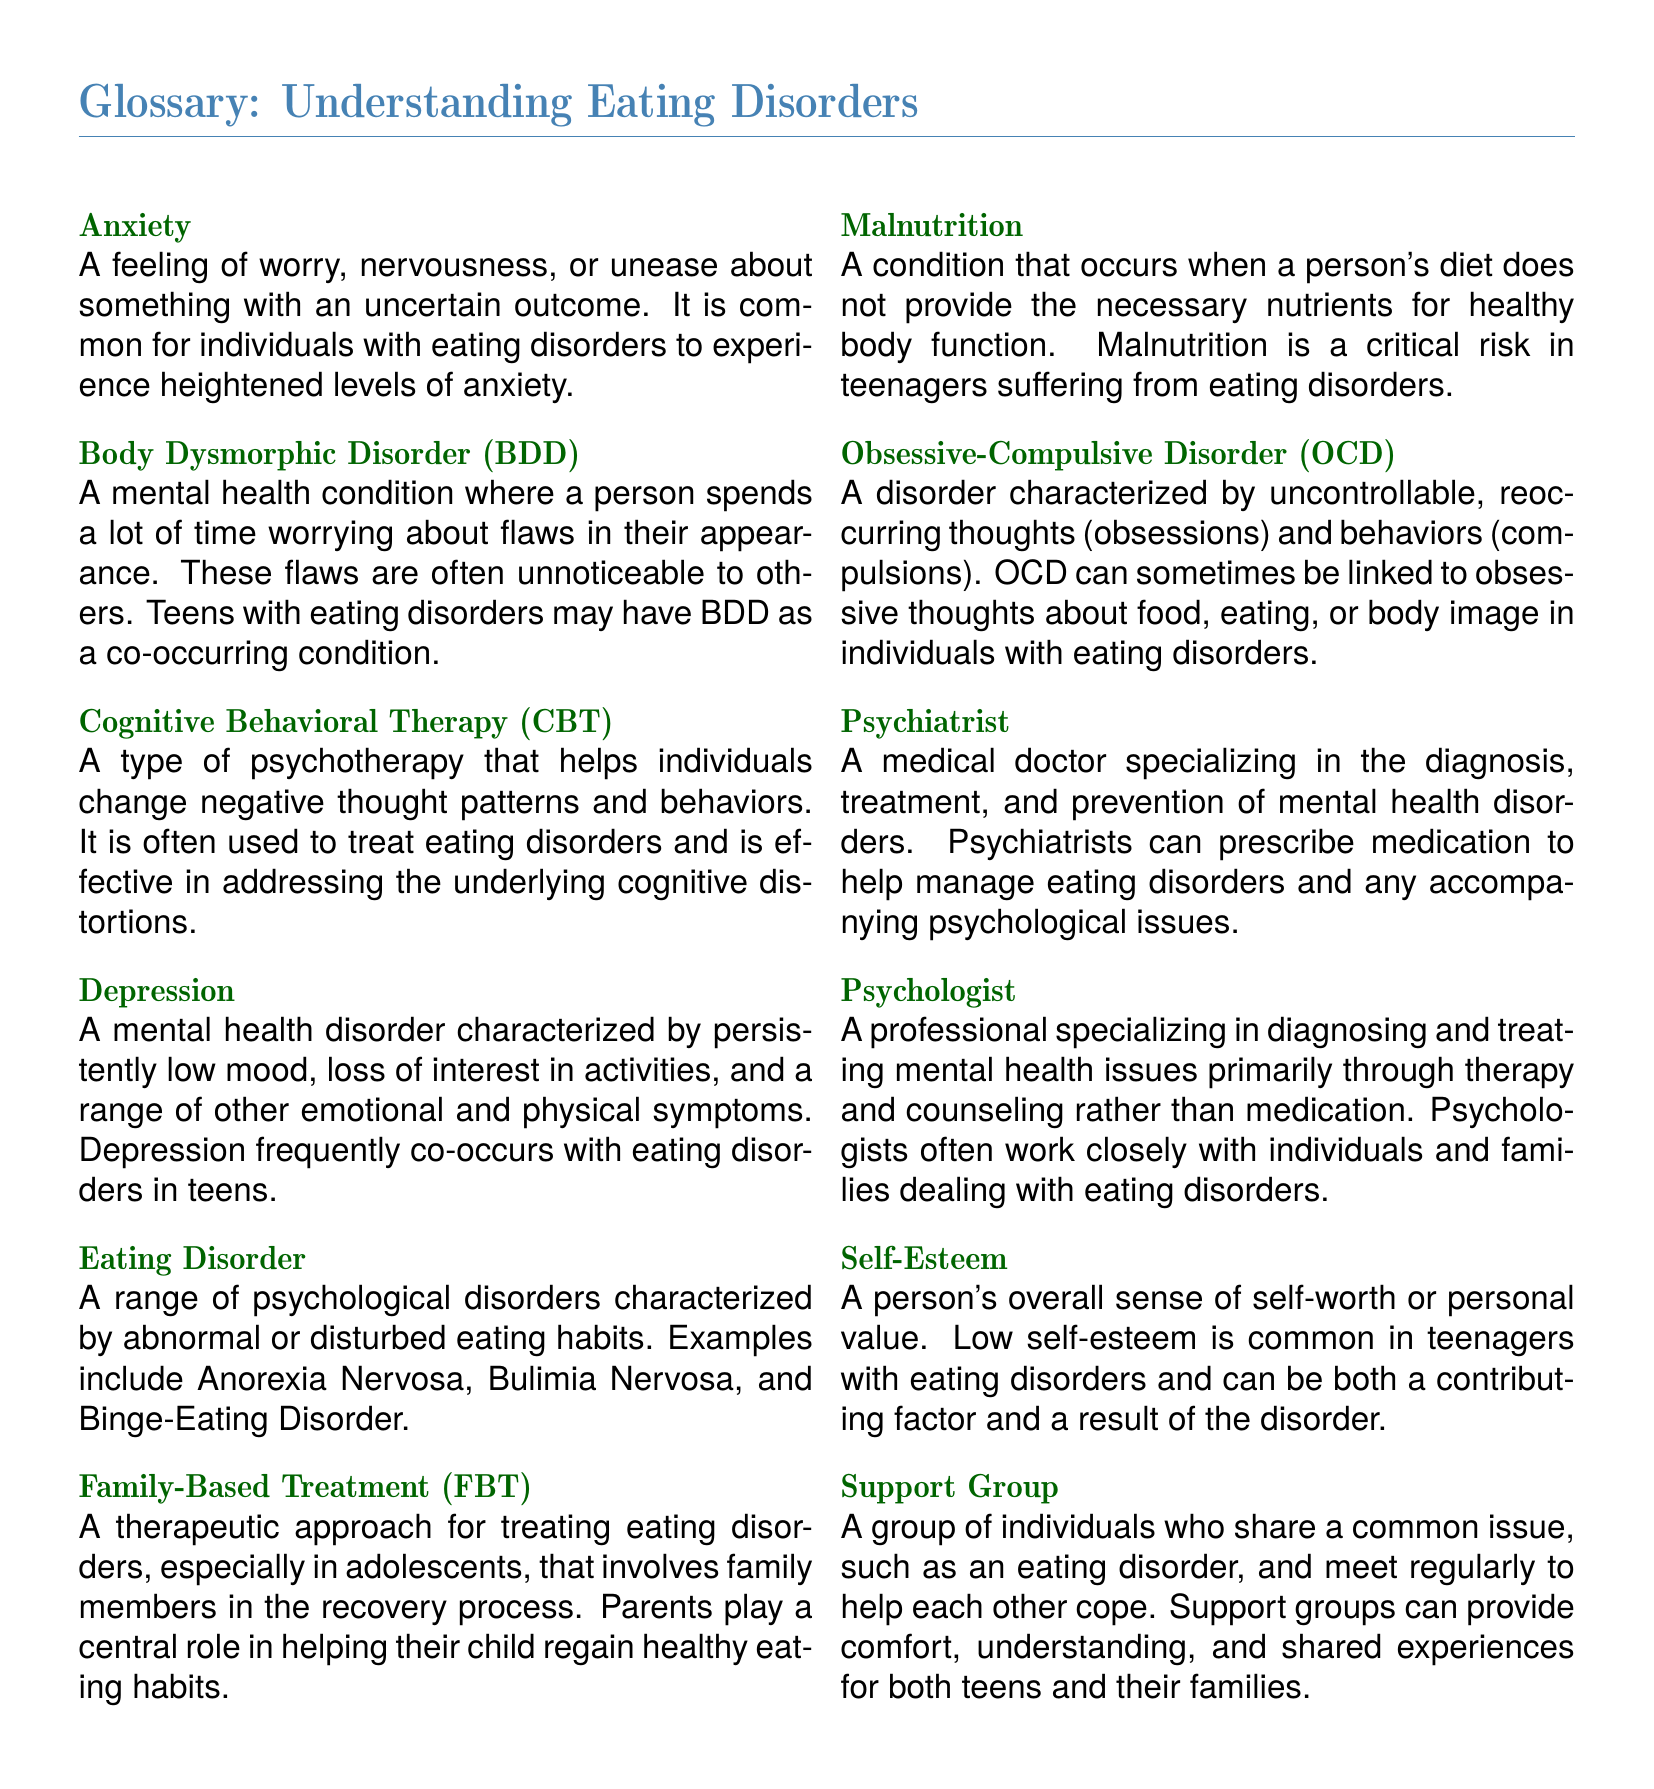What is Body Dysmorphic Disorder? Body Dysmorphic Disorder is defined in the document as a mental health condition where a person spends time worrying about flaws in their appearance.
Answer: A mental health condition worrying about flaws in appearance What are the common eating disorders listed? The document specifies examples of eating disorders such as Anorexia Nervosa, Bulimia Nervosa, and Binge-Eating Disorder.
Answer: Anorexia Nervosa, Bulimia Nervosa, Binge-Eating Disorder What treatment involves family members? Family-Based Treatment is mentioned as a therapeutic approach that involves family members in the recovery process.
Answer: Family-Based Treatment Which mental health condition is characterized by low mood? The document describes Depression as a mental health disorder characterized by persistently low mood.
Answer: Depression How does low self-esteem relate to eating disorders? The glossary states that low self-esteem is common in teenagers with eating disorders and can be a contributing factor.
Answer: Contributing factor to eating disorders Which therapy is effective for eating disorders? Cognitive Behavioral Therapy is included in the document as a type of psychotherapy that helps change negative thought patterns.
Answer: Cognitive Behavioral Therapy What role does a psychiatrist play? The document indicates that a psychiatrist specializes in the diagnosis, treatment, and prevention of mental health disorders, including prescribing medication.
Answer: Diagnosis and treatment of mental health disorders What is a Support Group? The document describes a Support Group as a collection of individuals sharing a common issue, such as an eating disorder, who meet regularly for support.
Answer: A group of individuals sharing a common issue 